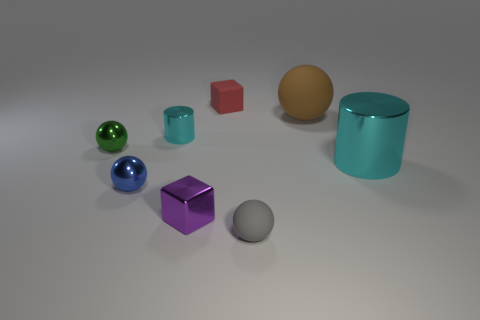What is the shape of the big thing that is behind the big cyan shiny thing?
Give a very brief answer. Sphere. Is the number of blocks that are on the left side of the green metallic sphere less than the number of green metallic objects in front of the small blue shiny thing?
Provide a short and direct response. No. There is a blue ball; does it have the same size as the cyan metallic cylinder that is left of the big cyan metallic cylinder?
Ensure brevity in your answer.  Yes. What number of blue matte objects are the same size as the blue ball?
Your answer should be compact. 0. What color is the large object that is the same material as the small purple object?
Your answer should be very brief. Cyan. Are there more red matte blocks than matte spheres?
Your response must be concise. No. Is the big cylinder made of the same material as the red block?
Make the answer very short. No. What shape is the red thing that is the same material as the gray ball?
Keep it short and to the point. Cube. Are there fewer large brown rubber cubes than gray rubber objects?
Your answer should be compact. Yes. There is a sphere that is behind the blue metallic thing and left of the big matte object; what material is it?
Ensure brevity in your answer.  Metal. 